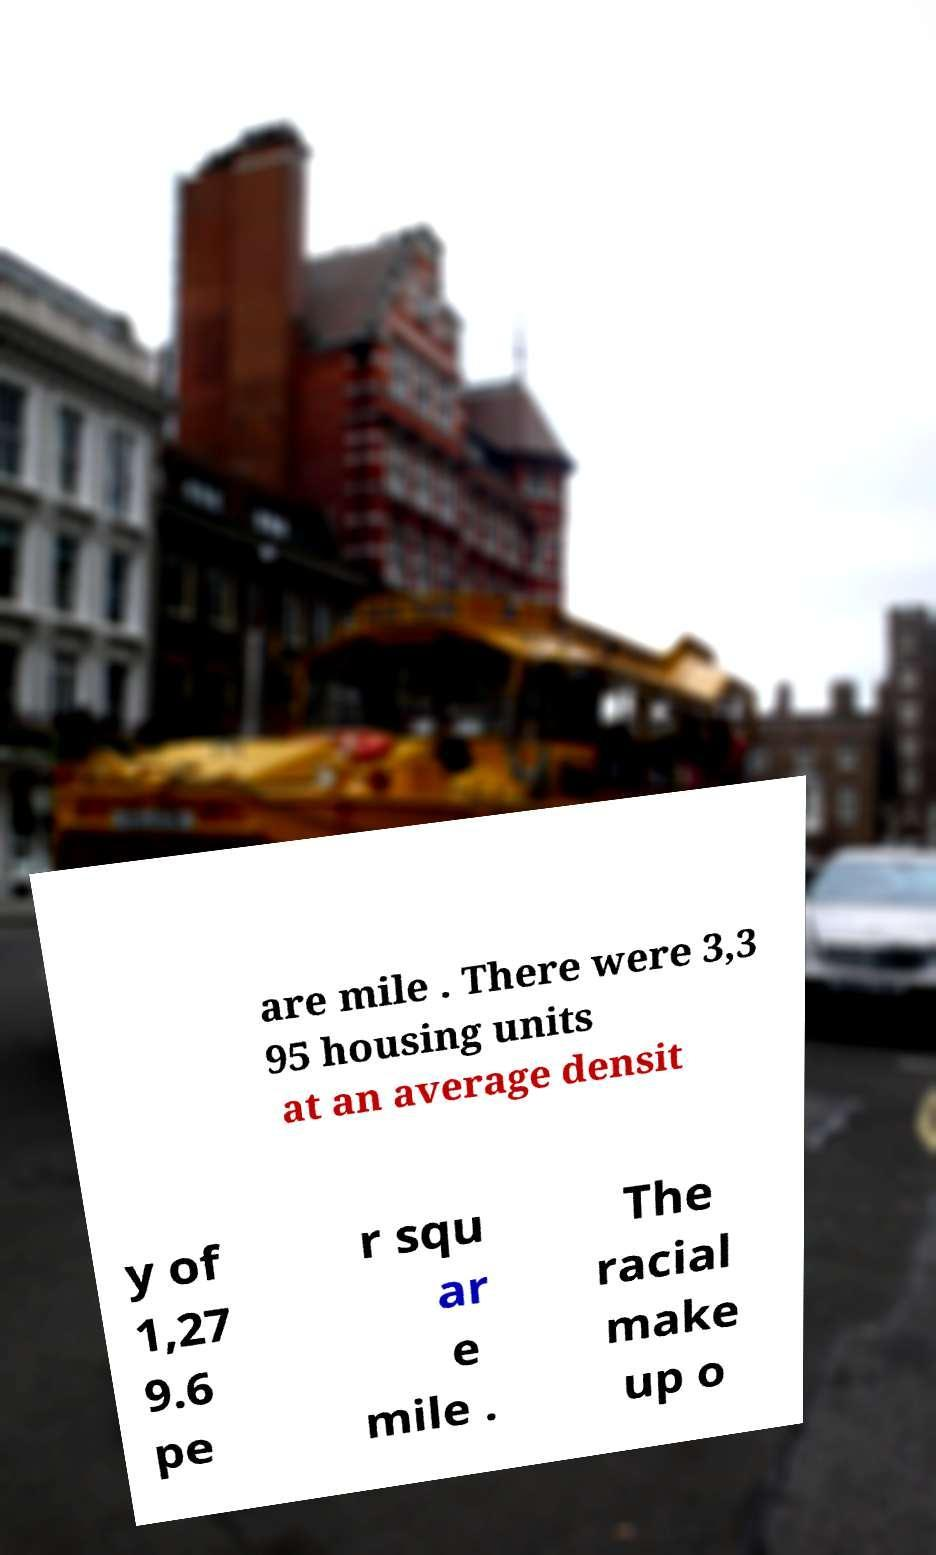Please identify and transcribe the text found in this image. are mile . There were 3,3 95 housing units at an average densit y of 1,27 9.6 pe r squ ar e mile . The racial make up o 